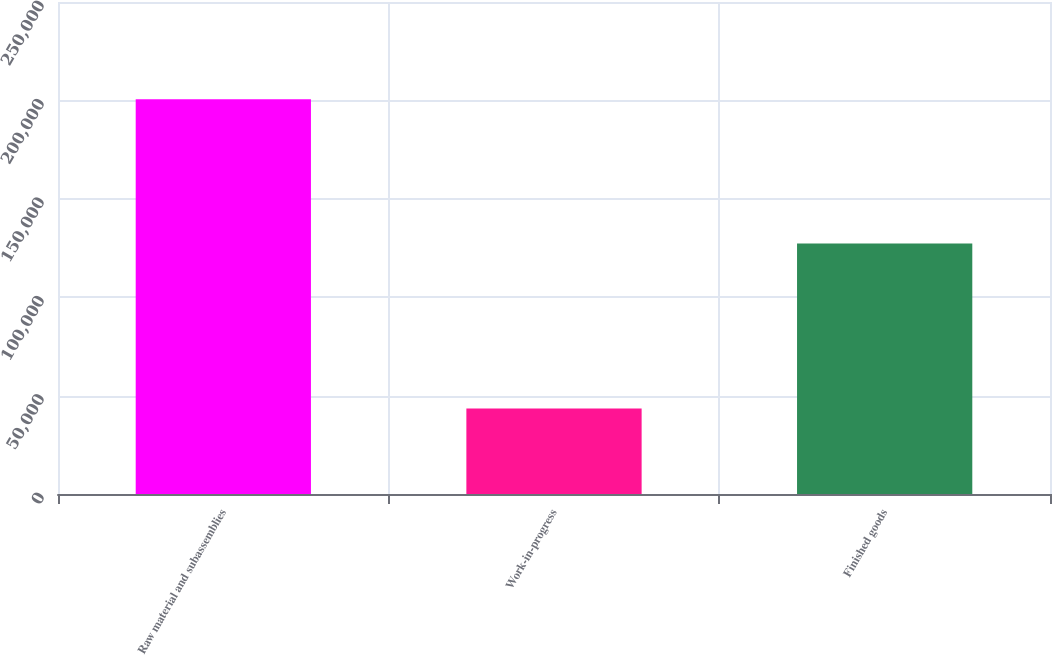<chart> <loc_0><loc_0><loc_500><loc_500><bar_chart><fcel>Raw material and subassemblies<fcel>Work-in-progress<fcel>Finished goods<nl><fcel>200640<fcel>43430<fcel>127301<nl></chart> 